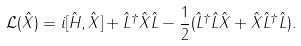<formula> <loc_0><loc_0><loc_500><loc_500>\mathcal { L } ( \hat { X } ) = i [ \hat { H } , \hat { X } ] + \hat { L } ^ { \dag } \hat { X } \hat { L } - \frac { 1 } { 2 } ( \hat { L } ^ { \dag } \hat { L } \hat { X } + \hat { X } \hat { L } ^ { \dag } \hat { L } ) .</formula> 